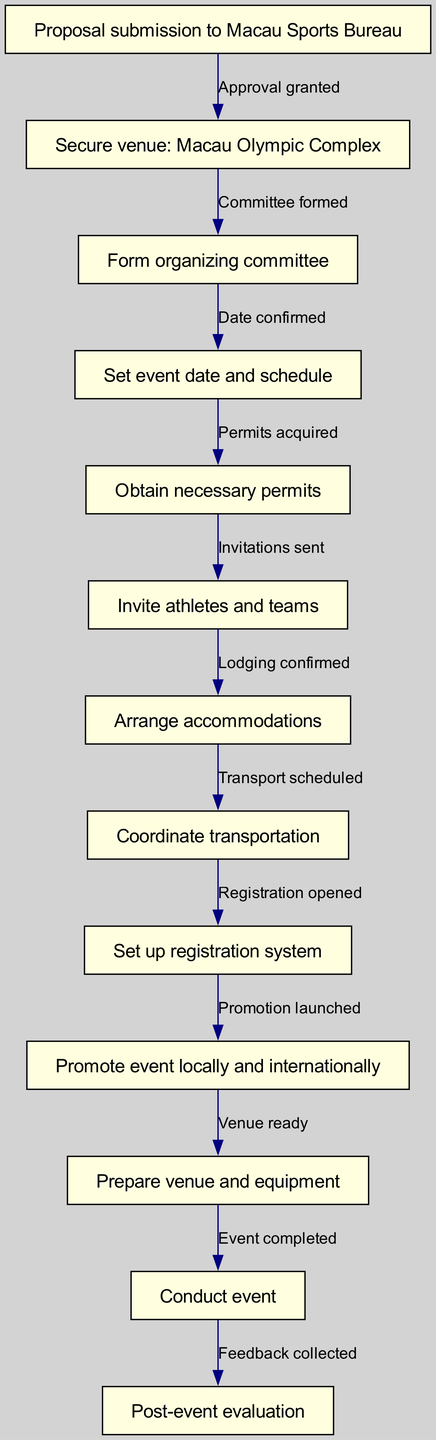What is the first step in organizing a sports event in Macau? The first step in the flow chart is "Proposal submission to Macau Sports Bureau," which indicates the initial action to commence the event planning process.
Answer: Proposal submission to Macau Sports Bureau How many nodes are there in the diagram? Counting the distinct steps outlined in the process provides a total of 12 nodes, each representing a step in organizing the sports event.
Answer: 12 What step follows "Form organizing committee"? Looking at the flow, the step that comes after "Form organizing committee" is "Set event date and schedule," indicating the sequential development of the organization process.
Answer: Set event date and schedule What permits need to be acquired after the event date is confirmed? After confirming the event date, the next action is "Obtain necessary permits," showing that the permits are crucial before moving further in organization.
Answer: Obtain necessary permits What is the last step in the flow? The final step illustrated in the flow chart is "Post-event evaluation," representing the concluding actions taken after the event has concluded.
Answer: Post-event evaluation If invitations are sent, which step happens right after? Following the step "Invite athletes and teams," the next step is "Arrange accommodations," showing the flow from inviting participants to ensuring their stay.
Answer: Arrange accommodations How many edges connect the nodes in the diagram? There are 11 edges connecting the 12 nodes, as each edge represents a transition between steps in the flow of organizing the event.
Answer: 11 What action is taken right before the event is conducted? Prior to conducting the event, the action "Prepare venue and equipment" must be completed, ensuring all preparations are in place.
Answer: Prepare venue and equipment What type of promotion is indicated in the flow chart? The flow chart states "Promote event locally and internationally," which specifies the scope of the promotional activities planned for the event.
Answer: Promote event locally and internationally 